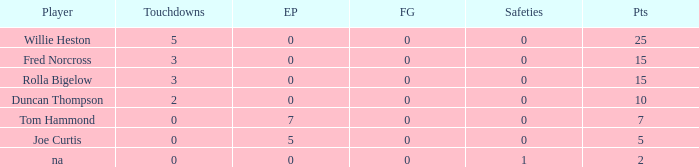How many Touchdowns have a Player of rolla bigelow, and an Extra points smaller than 0? None. 